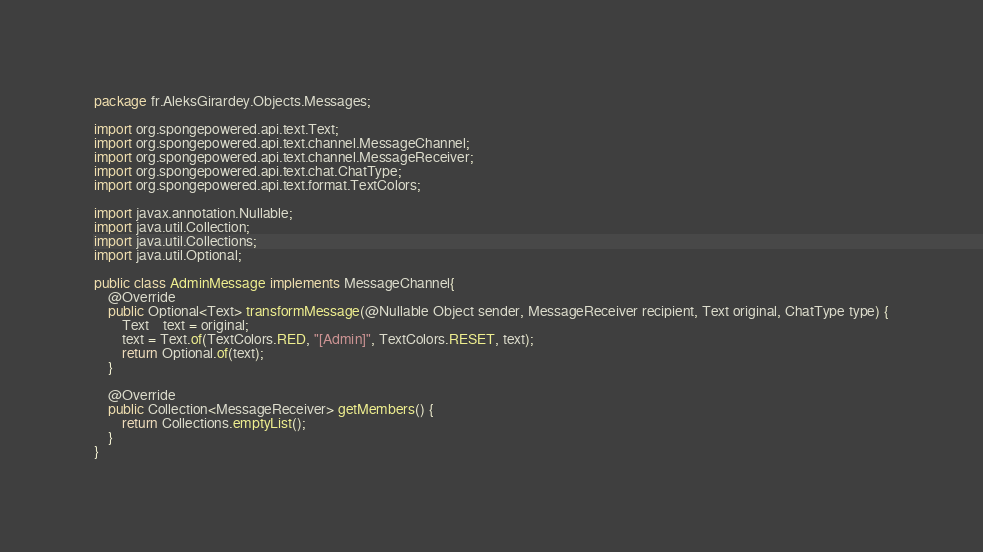Convert code to text. <code><loc_0><loc_0><loc_500><loc_500><_Java_>package fr.AleksGirardey.Objects.Messages;

import org.spongepowered.api.text.Text;
import org.spongepowered.api.text.channel.MessageChannel;
import org.spongepowered.api.text.channel.MessageReceiver;
import org.spongepowered.api.text.chat.ChatType;
import org.spongepowered.api.text.format.TextColors;

import javax.annotation.Nullable;
import java.util.Collection;
import java.util.Collections;
import java.util.Optional;

public class AdminMessage implements MessageChannel{
    @Override
    public Optional<Text> transformMessage(@Nullable Object sender, MessageReceiver recipient, Text original, ChatType type) {
        Text    text = original;
        text = Text.of(TextColors.RED, "[Admin]", TextColors.RESET, text);
        return Optional.of(text);
    }

    @Override
    public Collection<MessageReceiver> getMembers() {
        return Collections.emptyList();
    }
}</code> 